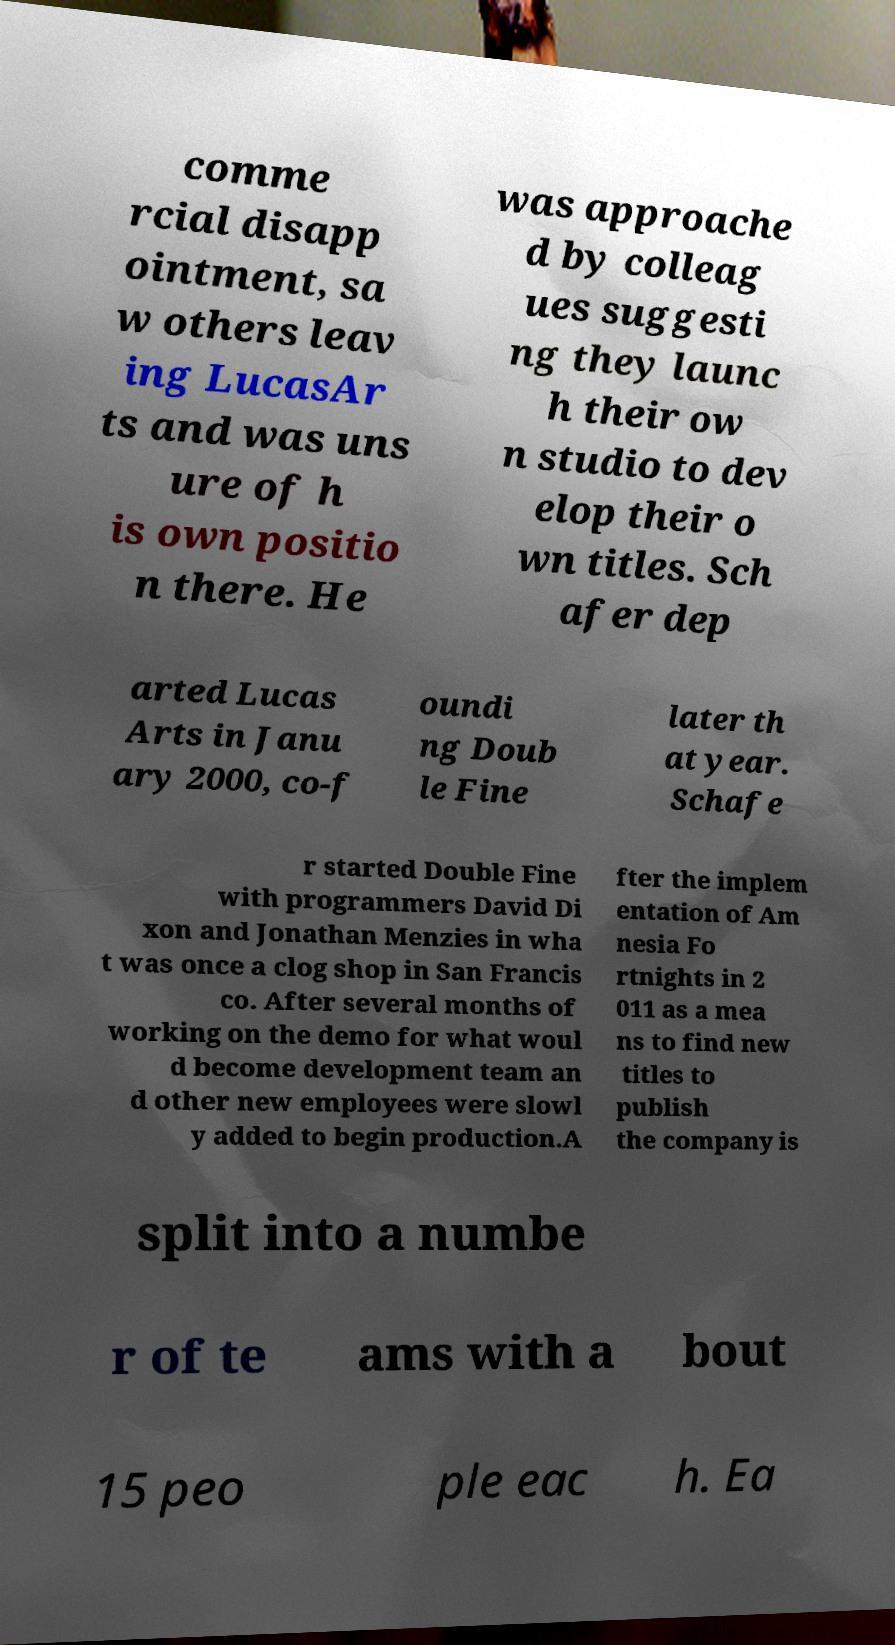There's text embedded in this image that I need extracted. Can you transcribe it verbatim? comme rcial disapp ointment, sa w others leav ing LucasAr ts and was uns ure of h is own positio n there. He was approache d by colleag ues suggesti ng they launc h their ow n studio to dev elop their o wn titles. Sch afer dep arted Lucas Arts in Janu ary 2000, co-f oundi ng Doub le Fine later th at year. Schafe r started Double Fine with programmers David Di xon and Jonathan Menzies in wha t was once a clog shop in San Francis co. After several months of working on the demo for what woul d become development team an d other new employees were slowl y added to begin production.A fter the implem entation of Am nesia Fo rtnights in 2 011 as a mea ns to find new titles to publish the company is split into a numbe r of te ams with a bout 15 peo ple eac h. Ea 